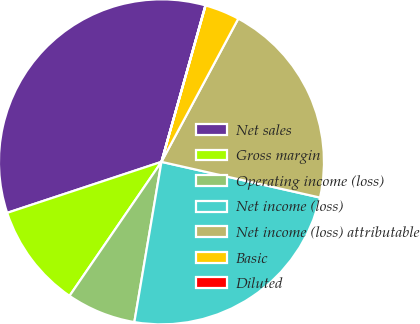Convert chart. <chart><loc_0><loc_0><loc_500><loc_500><pie_chart><fcel>Net sales<fcel>Gross margin<fcel>Operating income (loss)<fcel>Net income (loss)<fcel>Net income (loss) attributable<fcel>Basic<fcel>Diluted<nl><fcel>34.44%<fcel>10.35%<fcel>6.9%<fcel>24.14%<fcel>20.69%<fcel>3.46%<fcel>0.02%<nl></chart> 